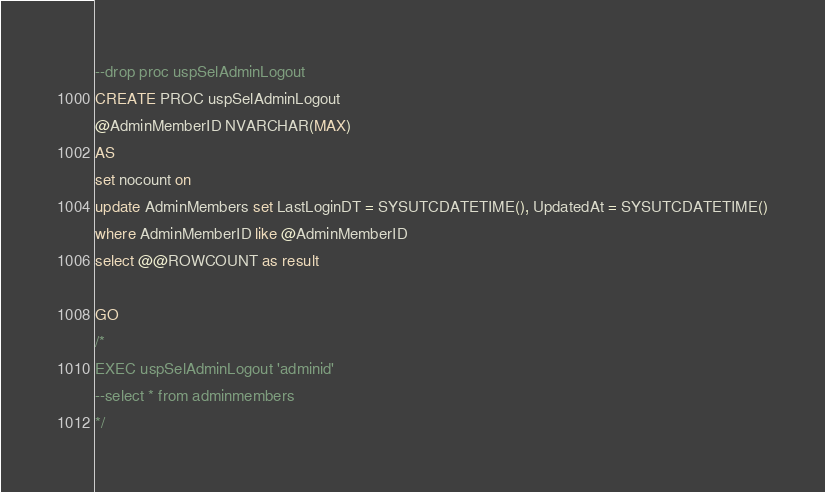Convert code to text. <code><loc_0><loc_0><loc_500><loc_500><_SQL_>--drop proc uspSelAdminLogout
CREATE PROC uspSelAdminLogout
@AdminMemberID NVARCHAR(MAX)
AS 
set nocount on
update AdminMembers set LastLoginDT = SYSUTCDATETIME(), UpdatedAt = SYSUTCDATETIME()
where AdminMemberID like @AdminMemberID
select @@ROWCOUNT as result

GO
/*
EXEC uspSelAdminLogout 'adminid'
--select * from adminmembers
*/</code> 